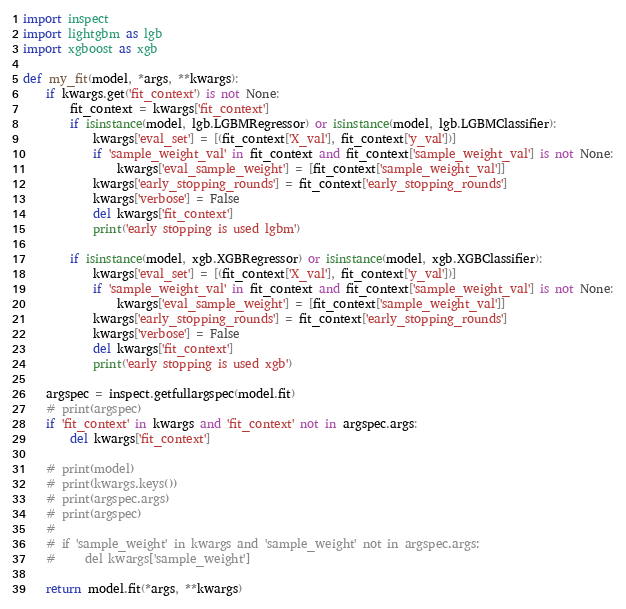Convert code to text. <code><loc_0><loc_0><loc_500><loc_500><_Python_>import inspect
import lightgbm as lgb
import xgboost as xgb

def my_fit(model, *args, **kwargs):
    if kwargs.get('fit_context') is not None:
        fit_context = kwargs['fit_context']
        if isinstance(model, lgb.LGBMRegressor) or isinstance(model, lgb.LGBMClassifier):
            kwargs['eval_set'] = [(fit_context['X_val'], fit_context['y_val'])]
            if 'sample_weight_val' in fit_context and fit_context['sample_weight_val'] is not None:
                kwargs['eval_sample_weight'] = [fit_context['sample_weight_val']]
            kwargs['early_stopping_rounds'] = fit_context['early_stopping_rounds']
            kwargs['verbose'] = False
            del kwargs['fit_context']
            print('early stopping is used lgbm')

        if isinstance(model, xgb.XGBRegressor) or isinstance(model, xgb.XGBClassifier):
            kwargs['eval_set'] = [(fit_context['X_val'], fit_context['y_val'])]
            if 'sample_weight_val' in fit_context and fit_context['sample_weight_val'] is not None:
                kwargs['eval_sample_weight'] = [fit_context['sample_weight_val']]
            kwargs['early_stopping_rounds'] = fit_context['early_stopping_rounds']
            kwargs['verbose'] = False
            del kwargs['fit_context']
            print('early stopping is used xgb')

    argspec = inspect.getfullargspec(model.fit)
    # print(argspec)
    if 'fit_context' in kwargs and 'fit_context' not in argspec.args:
        del kwargs['fit_context']

    # print(model)
    # print(kwargs.keys())
    # print(argspec.args)
    # print(argspec)
    #
    # if 'sample_weight' in kwargs and 'sample_weight' not in argspec.args:
    #     del kwargs['sample_weight']

    return model.fit(*args, **kwargs)
</code> 